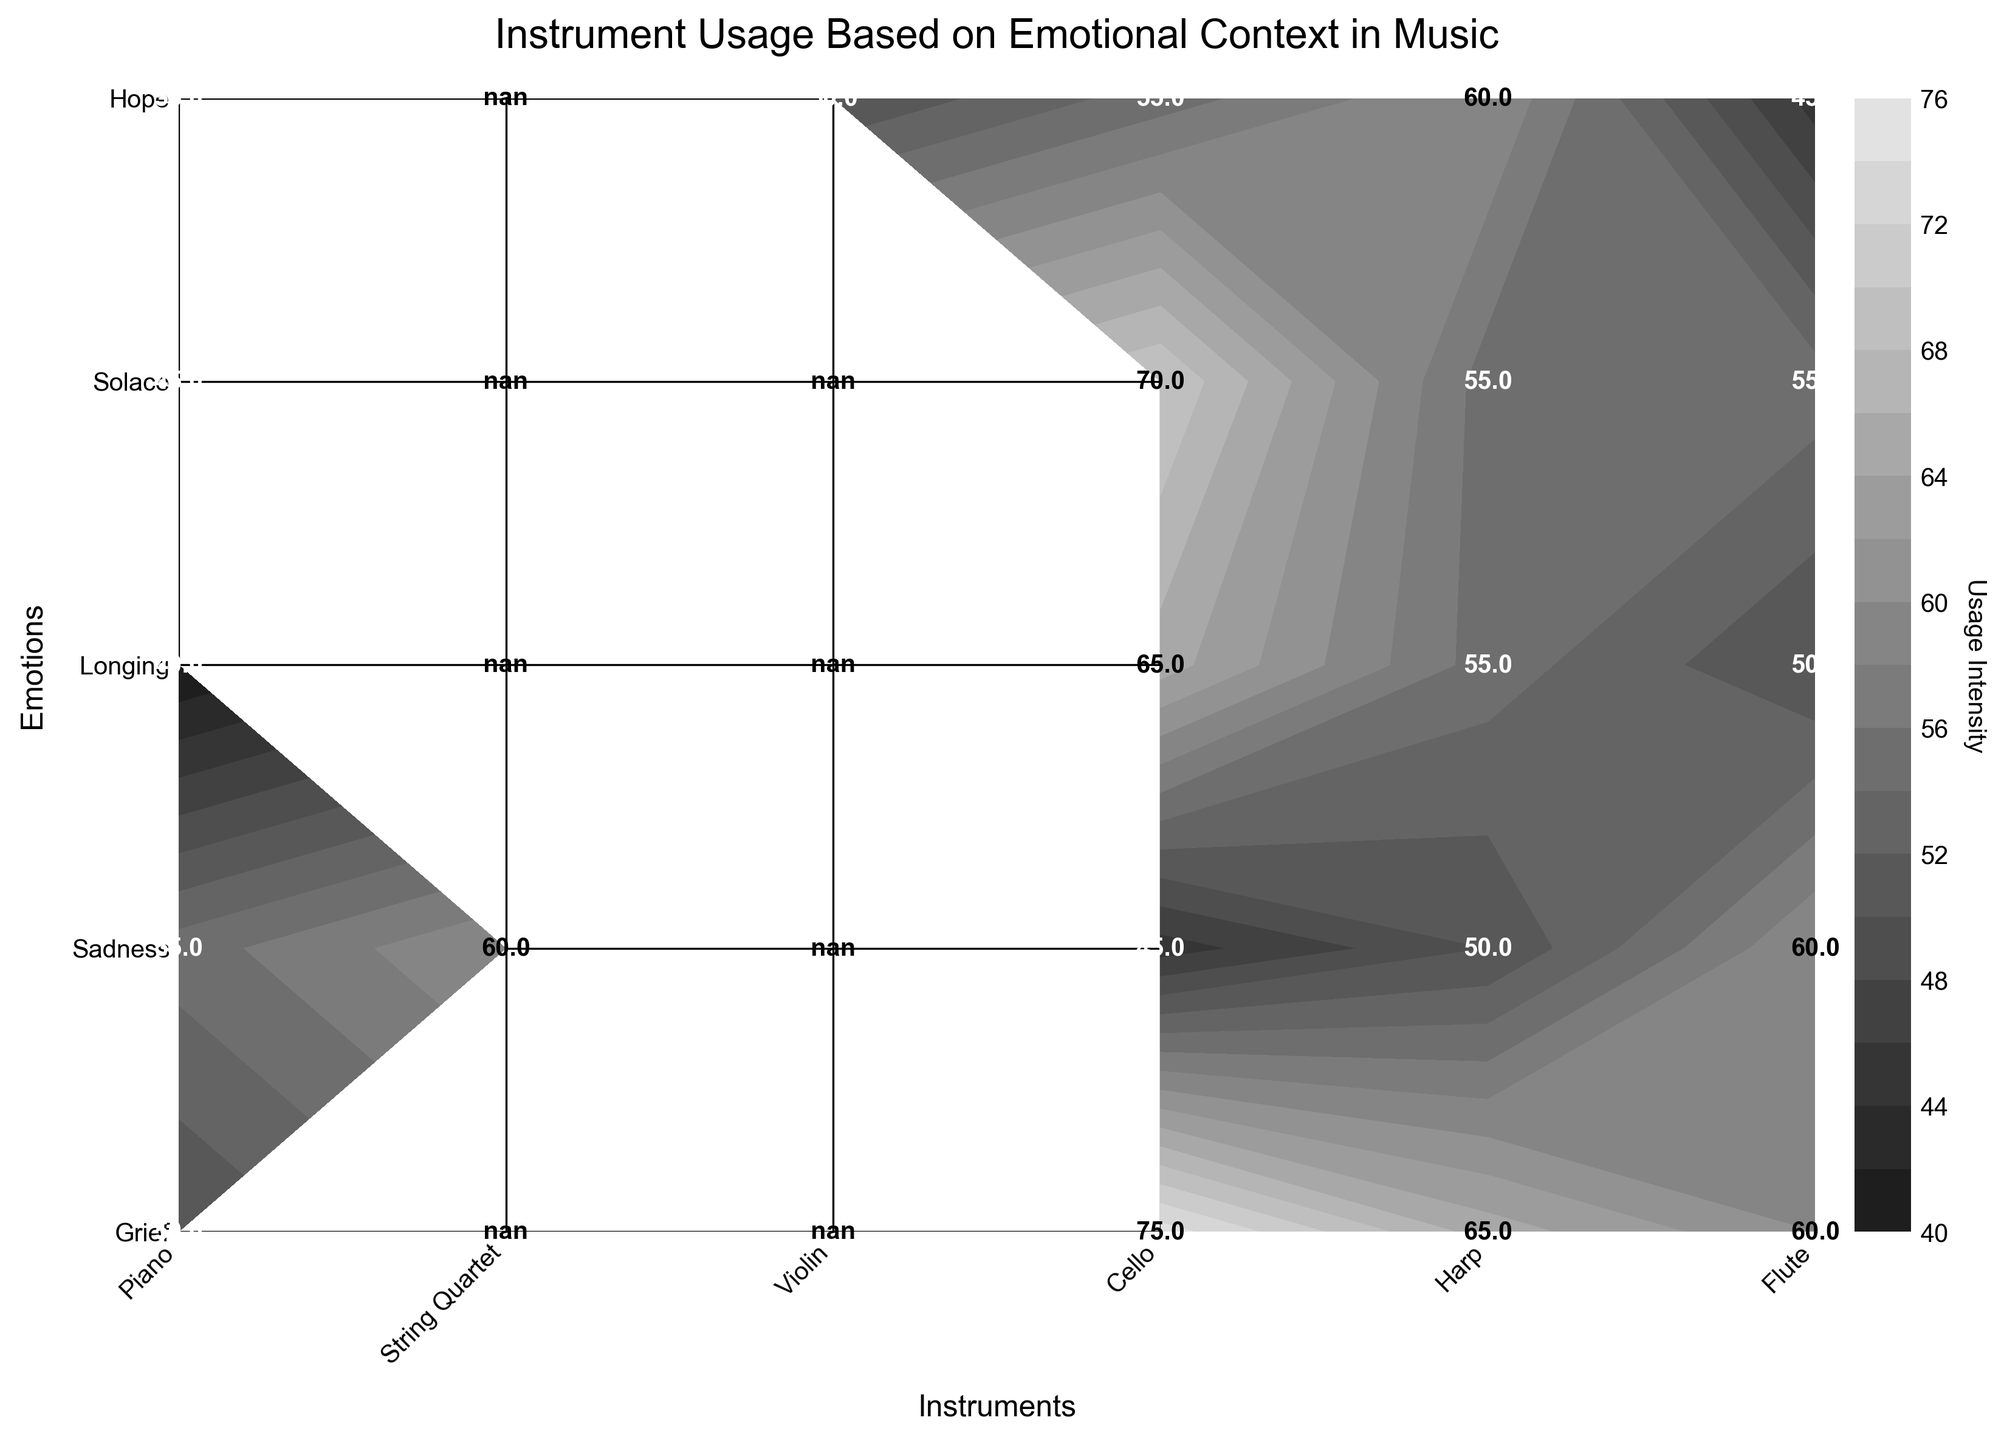What is the title of the plot? The title is located at the top of the plot and reads: "Instrument Usage Based on Emotional Context in Music".
Answer: Instrument Usage Based on Emotional Context in Music Which instrument has the highest usage for the emotion "Grief"? Look at the row corresponding to "Grief" and identify the instrument with the highest usage value. The highest value is for the Piano with a usage of 75.
Answer: Piano Which emotions and instruments received a usage intensity of 55 exactly? Check the plot for usage values of 55 and note the emotion-instrument pairs. The pairs are: Sadness - Cello, Longing - String Quartet, Solace - Harp, and Hope - String Quartet.
Answer: Sadness - Cello, Longing - String Quartet, Solace - Harp, Hope - String Quartet For the emotion "Hope", which instrument has the least usage? Look at the row corresponding to "Hope" and identify the instrument with the lowest usage value. The Piano has the lowest value at 45.
Answer: Piano Compare the usage values of the Cello and Violin for the emotion "Sadness". Which one is higher and by how much? Check the row for "Sadness" and compare the values for Cello (45) and Violin (55). The Violin has a higher usage by 10 units.
Answer: Violin by 10 units What is the average usage value for all instruments for the emotion "Solace"? Sum the usage values for Solace (Piano: 55, String Quartet: 60, Violin: 45, Cello: 55, Harp: 50) and divide by the number of instruments (5). (55+60+45+55+50)/5 = 53
Answer: 53 Which emotion has the most variance in usage values across all instruments? Calculate the range (max - min) for each emotion and compare them. "Hope" has the highest variance with Piano: 45 and Flute: 60, a range of 15.
Answer: Hope What is the total usage of the String Quartet instrument across all emotions? Add the usage values for the String Quartet across all emotions. (65+55+55+60+50) = 285
Answer: 285 Is there any instrument that has a consistent usage value across multiple emotions? If so, name it. Check for instruments with the same usage value across different emotions. The Cello has a consistent usage value of 55 for Solace and Hope.
Answer: Cello What is the median usage value for the Piano across all emotions? List the Piano usage values (75, 70, 65, 55, 45) and find the middle value. Sorted values: (45, 55, 65, 70, 75), the median is 65.
Answer: 65 